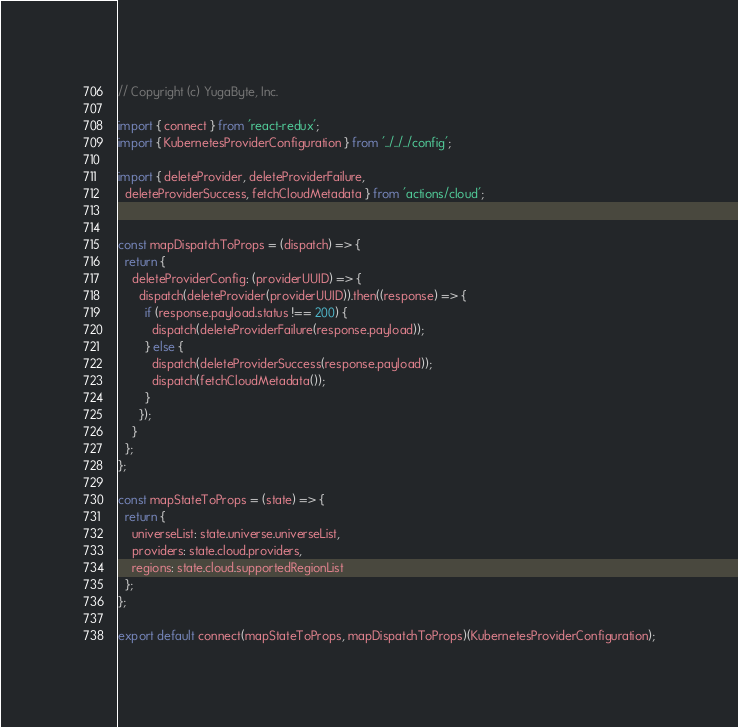Convert code to text. <code><loc_0><loc_0><loc_500><loc_500><_JavaScript_>// Copyright (c) YugaByte, Inc.

import { connect } from 'react-redux';
import { KubernetesProviderConfiguration } from '../../../config';

import { deleteProvider, deleteProviderFailure,
  deleteProviderSuccess, fetchCloudMetadata } from 'actions/cloud';


const mapDispatchToProps = (dispatch) => {
  return {
    deleteProviderConfig: (providerUUID) => {
      dispatch(deleteProvider(providerUUID)).then((response) => {
        if (response.payload.status !== 200) {
          dispatch(deleteProviderFailure(response.payload));
        } else {
          dispatch(deleteProviderSuccess(response.payload));
          dispatch(fetchCloudMetadata());
        }
      });
    }
  };
};

const mapStateToProps = (state) => {
  return {
    universeList: state.universe.universeList,
    providers: state.cloud.providers,
    regions: state.cloud.supportedRegionList
  };
};

export default connect(mapStateToProps, mapDispatchToProps)(KubernetesProviderConfiguration);
</code> 